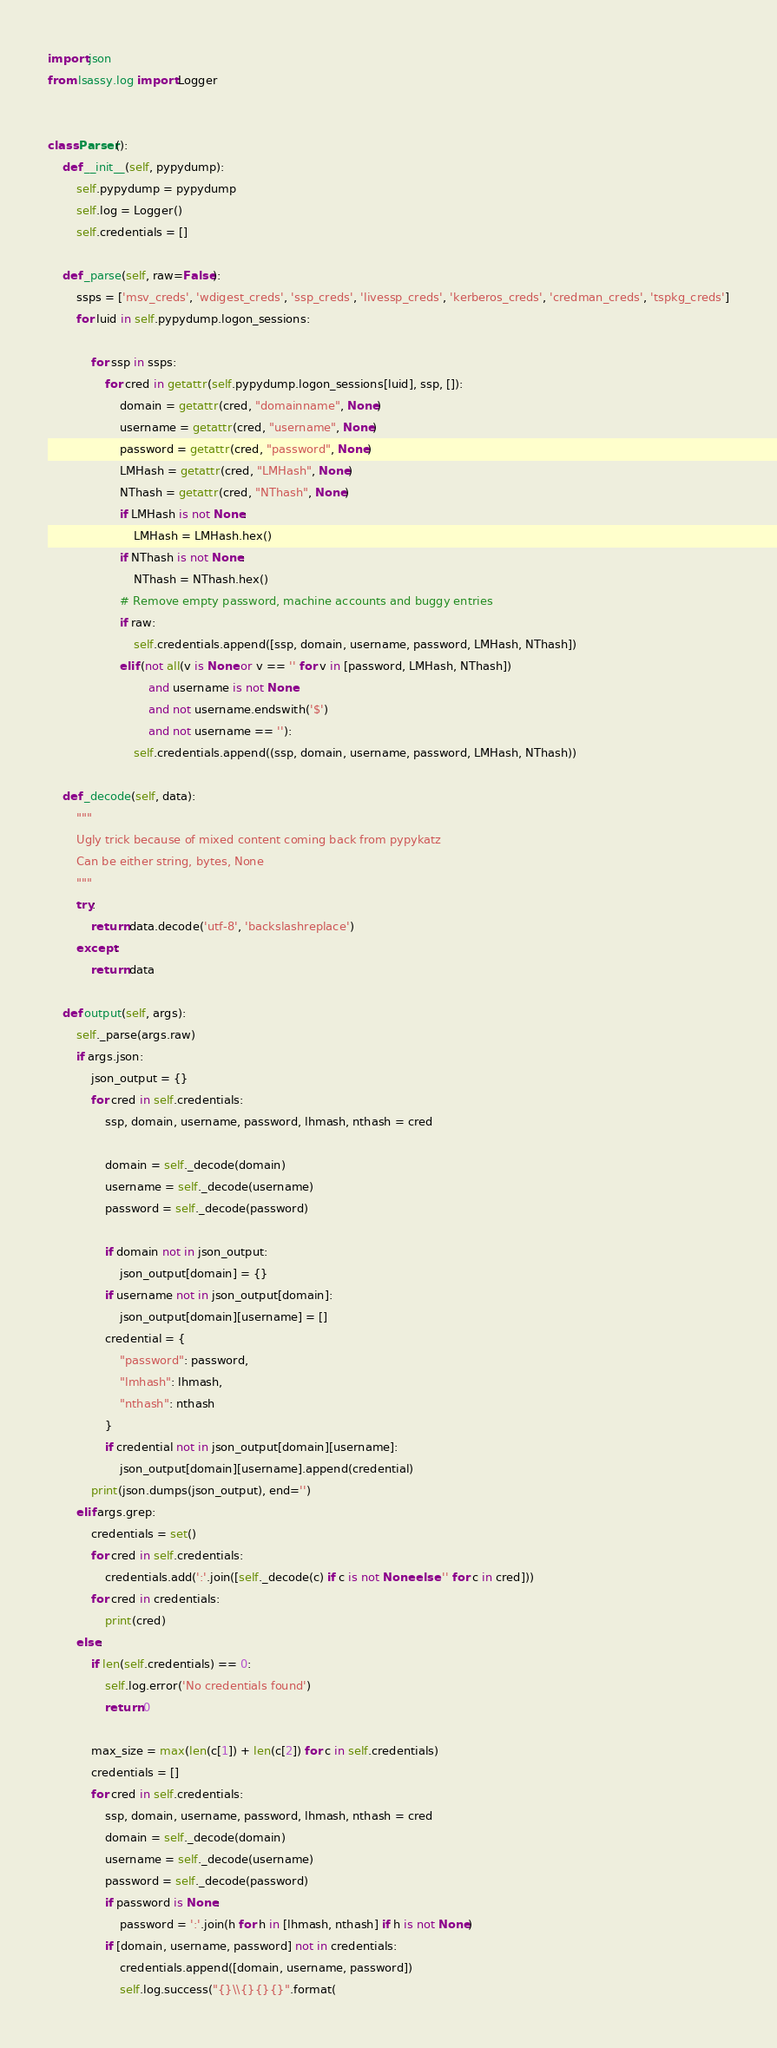<code> <loc_0><loc_0><loc_500><loc_500><_Python_>import json
from lsassy.log import Logger


class Parser():
    def __init__(self, pypydump):
        self.pypydump = pypydump
        self.log = Logger()
        self.credentials = []
    
    def _parse(self, raw=False):
        ssps = ['msv_creds', 'wdigest_creds', 'ssp_creds', 'livessp_creds', 'kerberos_creds', 'credman_creds', 'tspkg_creds']
        for luid in self.pypydump.logon_sessions:
            
            for ssp in ssps:
                for cred in getattr(self.pypydump.logon_sessions[luid], ssp, []):
                    domain = getattr(cred, "domainname", None)
                    username = getattr(cred, "username", None)
                    password = getattr(cred, "password", None)
                    LMHash = getattr(cred, "LMHash", None)
                    NThash = getattr(cred, "NThash", None)
                    if LMHash is not None:
                        LMHash = LMHash.hex()
                    if NThash is not None:
                        NThash = NThash.hex()
                    # Remove empty password, machine accounts and buggy entries
                    if raw:
                        self.credentials.append([ssp, domain, username, password, LMHash, NThash])
                    elif (not all(v is None or v == '' for v in [password, LMHash, NThash])
                            and username is not None
                            and not username.endswith('$')
                            and not username == ''):
                        self.credentials.append((ssp, domain, username, password, LMHash, NThash))

    def _decode(self, data):
        """
        Ugly trick because of mixed content coming back from pypykatz
        Can be either string, bytes, None
        """
        try:
            return data.decode('utf-8', 'backslashreplace')
        except:
            return data

    def output(self, args):
        self._parse(args.raw)
        if args.json:
            json_output = {}
            for cred in self.credentials:
                ssp, domain, username, password, lhmash, nthash = cred

                domain = self._decode(domain)
                username = self._decode(username)
                password = self._decode(password)

                if domain not in json_output:
                    json_output[domain] = {}
                if username not in json_output[domain]:
                    json_output[domain][username] = []
                credential = {
                    "password": password,
                    "lmhash": lhmash,
                    "nthash": nthash
                }
                if credential not in json_output[domain][username]:
                    json_output[domain][username].append(credential)
            print(json.dumps(json_output), end='')
        elif args.grep:
            credentials = set()
            for cred in self.credentials:
                credentials.add(':'.join([self._decode(c) if c is not None else '' for c in cred]))
            for cred in credentials:
                print(cred)
        else:
            if len(self.credentials) == 0:
                self.log.error('No credentials found')
                return 0

            max_size = max(len(c[1]) + len(c[2]) for c in self.credentials)
            credentials = []
            for cred in self.credentials:
                ssp, domain, username, password, lhmash, nthash = cred
                domain = self._decode(domain)
                username = self._decode(username)
                password = self._decode(password)
                if password is None:
                    password = ':'.join(h for h in [lhmash, nthash] if h is not None)
                if [domain, username, password] not in credentials:
                    credentials.append([domain, username, password])
                    self.log.success("{}\\{}{}{}".format(</code> 